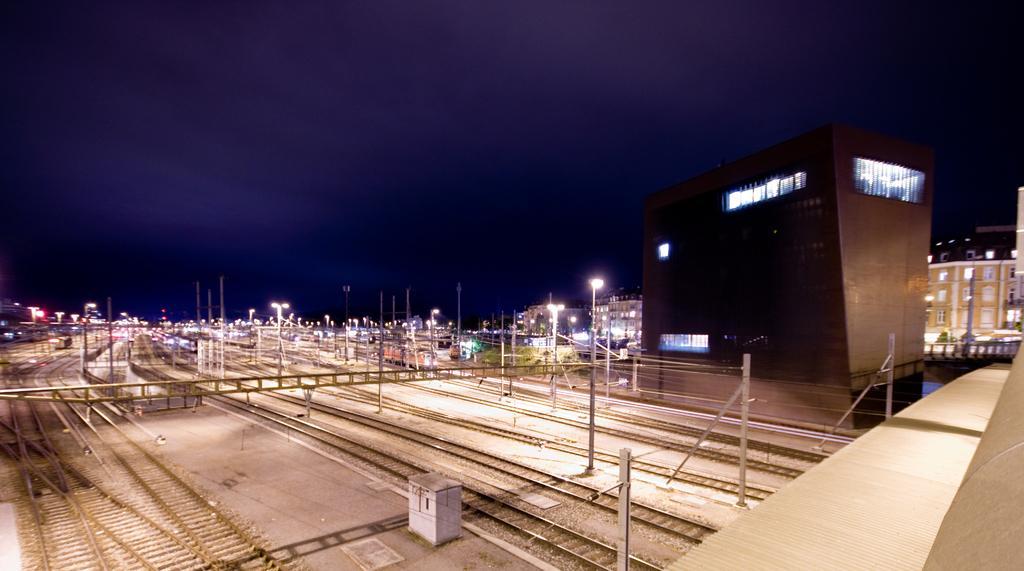Please provide a concise description of this image. In this image we can see railway tracks, electricity poles, buildings, street lights, sky and clouds. 